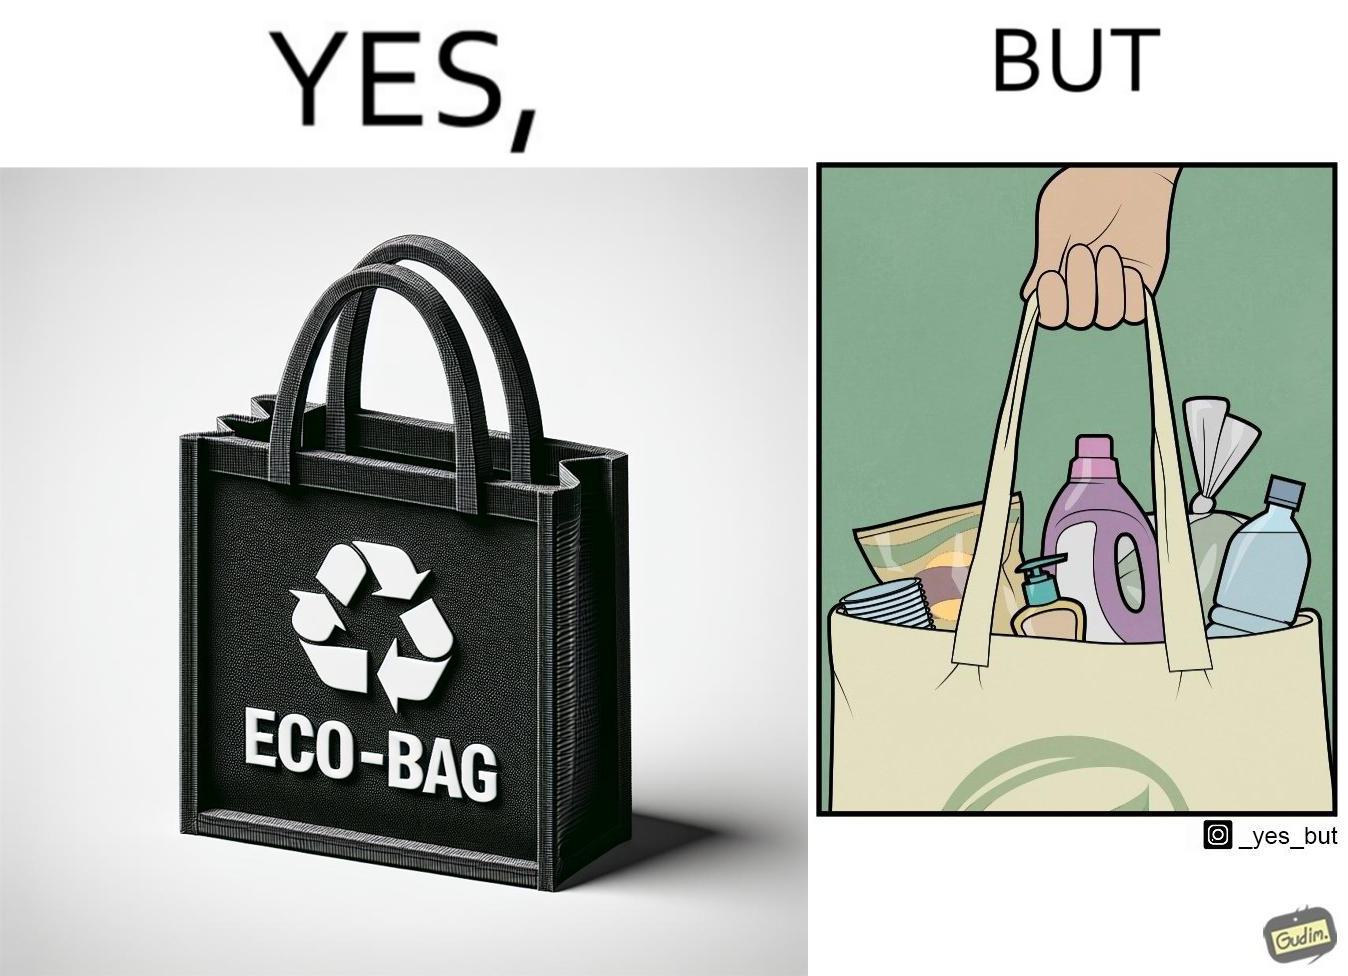Describe the contrast between the left and right parts of this image. In the left part of the image: a bag with text "eco-bag" on it, probably made up of some eco-friendly materials like cotton or jute In the right part of the image: a person carrying different products inside plastic containers or plastic wrapping in a carry bag 